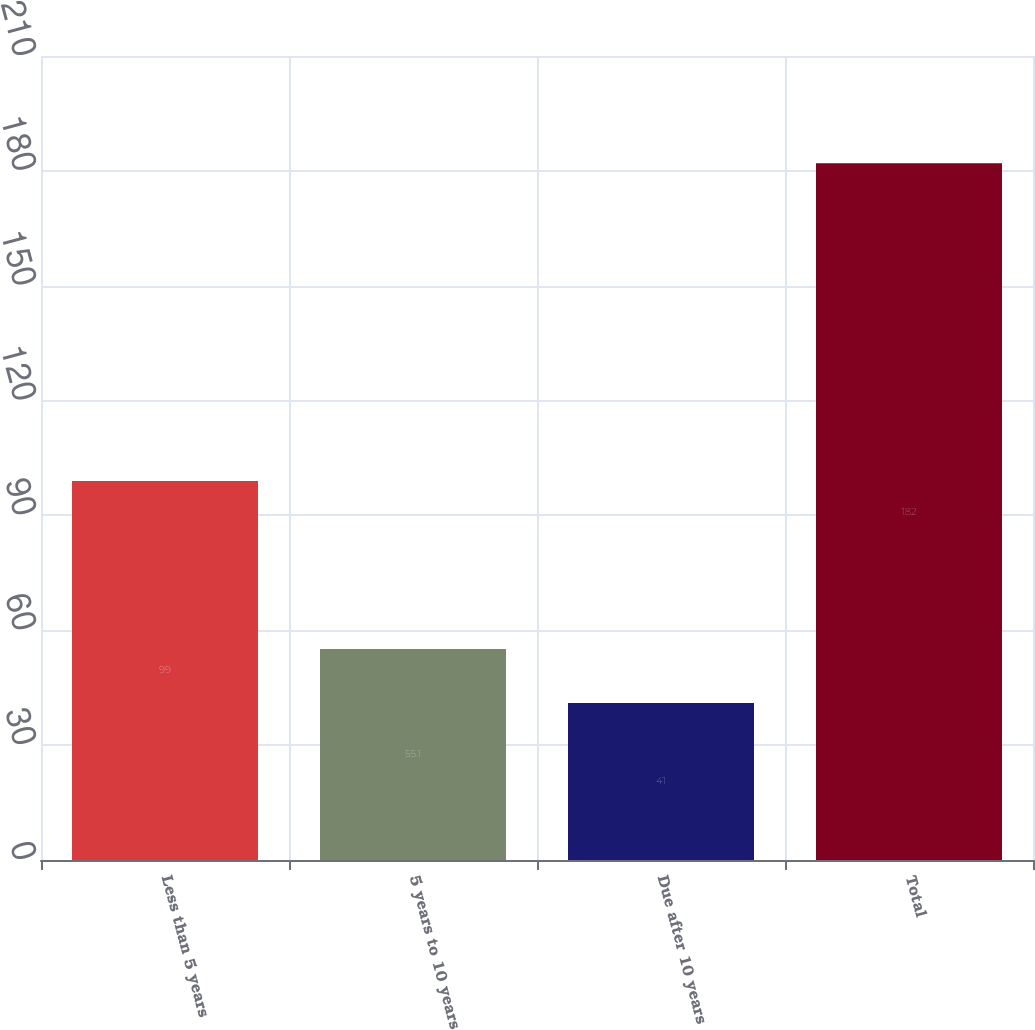<chart> <loc_0><loc_0><loc_500><loc_500><bar_chart><fcel>Less than 5 years<fcel>5 years to 10 years<fcel>Due after 10 years<fcel>Total<nl><fcel>99<fcel>55.1<fcel>41<fcel>182<nl></chart> 